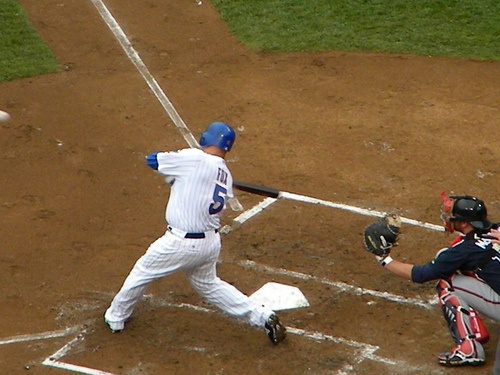Describe the objects in this image and their specific colors. I can see people in darkgreen, lavender, darkgray, gray, and maroon tones, people in darkgreen, black, darkgray, gray, and brown tones, baseball glove in darkgreen, black, gray, and tan tones, baseball bat in darkgreen, black, and gray tones, and sports ball in darkgreen, brown, gray, and darkgray tones in this image. 